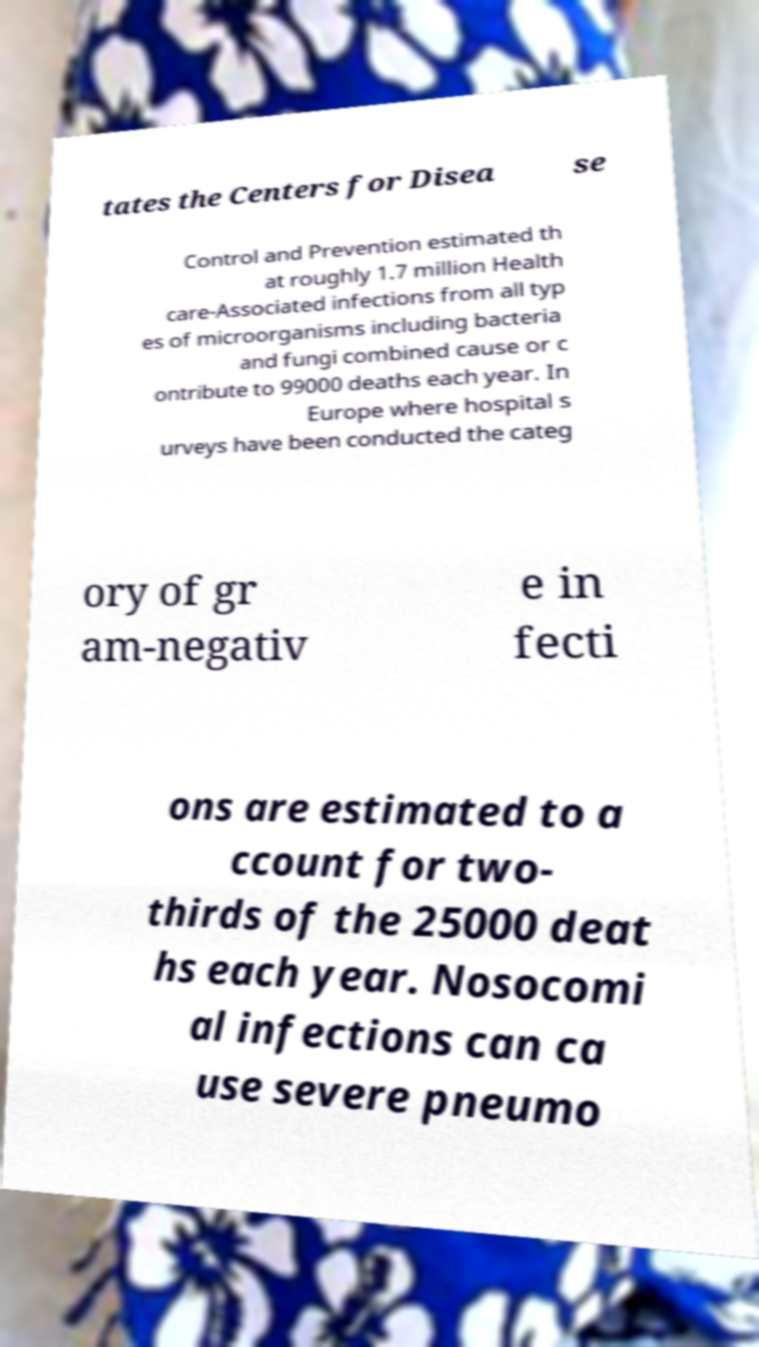For documentation purposes, I need the text within this image transcribed. Could you provide that? tates the Centers for Disea se Control and Prevention estimated th at roughly 1.7 million Health care-Associated infections from all typ es of microorganisms including bacteria and fungi combined cause or c ontribute to 99000 deaths each year. In Europe where hospital s urveys have been conducted the categ ory of gr am-negativ e in fecti ons are estimated to a ccount for two- thirds of the 25000 deat hs each year. Nosocomi al infections can ca use severe pneumo 